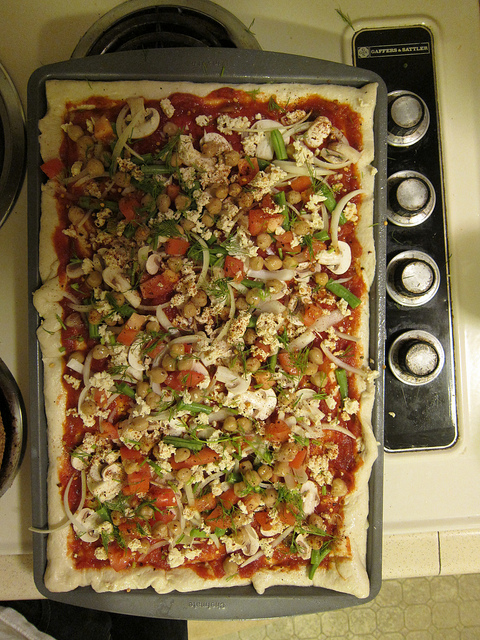Please transcribe the text information in this image. LATTLED 